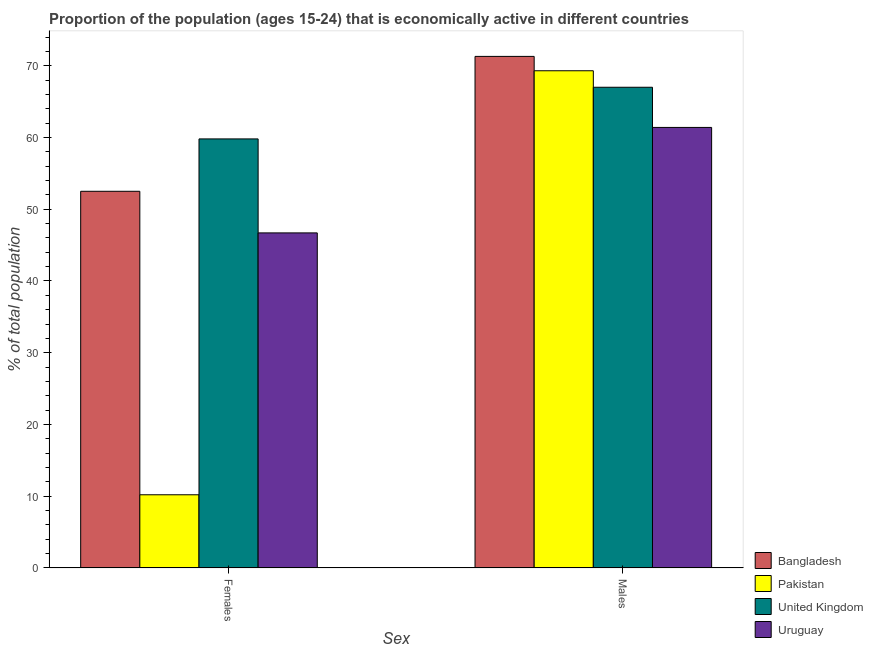How many different coloured bars are there?
Offer a terse response. 4. How many groups of bars are there?
Provide a succinct answer. 2. How many bars are there on the 1st tick from the left?
Ensure brevity in your answer.  4. How many bars are there on the 1st tick from the right?
Provide a succinct answer. 4. What is the label of the 2nd group of bars from the left?
Your answer should be compact. Males. What is the percentage of economically active female population in Pakistan?
Your answer should be very brief. 10.2. Across all countries, what is the maximum percentage of economically active male population?
Give a very brief answer. 71.3. Across all countries, what is the minimum percentage of economically active female population?
Your answer should be very brief. 10.2. In which country was the percentage of economically active female population maximum?
Make the answer very short. United Kingdom. In which country was the percentage of economically active male population minimum?
Keep it short and to the point. Uruguay. What is the total percentage of economically active female population in the graph?
Keep it short and to the point. 169.2. What is the difference between the percentage of economically active male population in Bangladesh and that in Pakistan?
Provide a short and direct response. 2. What is the difference between the percentage of economically active male population in Bangladesh and the percentage of economically active female population in United Kingdom?
Provide a short and direct response. 11.5. What is the average percentage of economically active female population per country?
Offer a terse response. 42.3. What is the difference between the percentage of economically active female population and percentage of economically active male population in United Kingdom?
Offer a terse response. -7.2. What is the ratio of the percentage of economically active male population in Bangladesh to that in Pakistan?
Offer a very short reply. 1.03. Is the percentage of economically active female population in United Kingdom less than that in Pakistan?
Your response must be concise. No. What does the 3rd bar from the left in Males represents?
Your response must be concise. United Kingdom. What does the 1st bar from the right in Males represents?
Provide a succinct answer. Uruguay. Are all the bars in the graph horizontal?
Give a very brief answer. No. How many countries are there in the graph?
Make the answer very short. 4. What is the difference between two consecutive major ticks on the Y-axis?
Make the answer very short. 10. Does the graph contain grids?
Your answer should be compact. No. Where does the legend appear in the graph?
Give a very brief answer. Bottom right. How many legend labels are there?
Provide a short and direct response. 4. What is the title of the graph?
Give a very brief answer. Proportion of the population (ages 15-24) that is economically active in different countries. Does "Italy" appear as one of the legend labels in the graph?
Offer a very short reply. No. What is the label or title of the X-axis?
Offer a terse response. Sex. What is the label or title of the Y-axis?
Your response must be concise. % of total population. What is the % of total population in Bangladesh in Females?
Make the answer very short. 52.5. What is the % of total population of Pakistan in Females?
Your answer should be very brief. 10.2. What is the % of total population in United Kingdom in Females?
Your response must be concise. 59.8. What is the % of total population in Uruguay in Females?
Offer a terse response. 46.7. What is the % of total population in Bangladesh in Males?
Offer a terse response. 71.3. What is the % of total population of Pakistan in Males?
Offer a very short reply. 69.3. What is the % of total population in Uruguay in Males?
Provide a succinct answer. 61.4. Across all Sex, what is the maximum % of total population in Bangladesh?
Provide a short and direct response. 71.3. Across all Sex, what is the maximum % of total population of Pakistan?
Your answer should be compact. 69.3. Across all Sex, what is the maximum % of total population of United Kingdom?
Make the answer very short. 67. Across all Sex, what is the maximum % of total population of Uruguay?
Your response must be concise. 61.4. Across all Sex, what is the minimum % of total population in Bangladesh?
Offer a terse response. 52.5. Across all Sex, what is the minimum % of total population of Pakistan?
Provide a succinct answer. 10.2. Across all Sex, what is the minimum % of total population of United Kingdom?
Make the answer very short. 59.8. Across all Sex, what is the minimum % of total population in Uruguay?
Your answer should be compact. 46.7. What is the total % of total population of Bangladesh in the graph?
Make the answer very short. 123.8. What is the total % of total population of Pakistan in the graph?
Your answer should be compact. 79.5. What is the total % of total population in United Kingdom in the graph?
Give a very brief answer. 126.8. What is the total % of total population of Uruguay in the graph?
Give a very brief answer. 108.1. What is the difference between the % of total population in Bangladesh in Females and that in Males?
Keep it short and to the point. -18.8. What is the difference between the % of total population of Pakistan in Females and that in Males?
Make the answer very short. -59.1. What is the difference between the % of total population of Uruguay in Females and that in Males?
Keep it short and to the point. -14.7. What is the difference between the % of total population in Bangladesh in Females and the % of total population in Pakistan in Males?
Make the answer very short. -16.8. What is the difference between the % of total population of Bangladesh in Females and the % of total population of Uruguay in Males?
Your answer should be compact. -8.9. What is the difference between the % of total population of Pakistan in Females and the % of total population of United Kingdom in Males?
Your answer should be very brief. -56.8. What is the difference between the % of total population of Pakistan in Females and the % of total population of Uruguay in Males?
Offer a terse response. -51.2. What is the difference between the % of total population of United Kingdom in Females and the % of total population of Uruguay in Males?
Ensure brevity in your answer.  -1.6. What is the average % of total population of Bangladesh per Sex?
Your answer should be compact. 61.9. What is the average % of total population in Pakistan per Sex?
Give a very brief answer. 39.75. What is the average % of total population in United Kingdom per Sex?
Provide a short and direct response. 63.4. What is the average % of total population in Uruguay per Sex?
Provide a succinct answer. 54.05. What is the difference between the % of total population of Bangladesh and % of total population of Pakistan in Females?
Provide a succinct answer. 42.3. What is the difference between the % of total population in Bangladesh and % of total population in United Kingdom in Females?
Keep it short and to the point. -7.3. What is the difference between the % of total population in Bangladesh and % of total population in Uruguay in Females?
Provide a short and direct response. 5.8. What is the difference between the % of total population in Pakistan and % of total population in United Kingdom in Females?
Make the answer very short. -49.6. What is the difference between the % of total population of Pakistan and % of total population of Uruguay in Females?
Your answer should be very brief. -36.5. What is the difference between the % of total population in United Kingdom and % of total population in Uruguay in Females?
Your response must be concise. 13.1. What is the difference between the % of total population of Bangladesh and % of total population of Pakistan in Males?
Your response must be concise. 2. What is the ratio of the % of total population of Bangladesh in Females to that in Males?
Ensure brevity in your answer.  0.74. What is the ratio of the % of total population of Pakistan in Females to that in Males?
Offer a terse response. 0.15. What is the ratio of the % of total population in United Kingdom in Females to that in Males?
Provide a succinct answer. 0.89. What is the ratio of the % of total population of Uruguay in Females to that in Males?
Keep it short and to the point. 0.76. What is the difference between the highest and the second highest % of total population in Bangladesh?
Offer a very short reply. 18.8. What is the difference between the highest and the second highest % of total population of Pakistan?
Provide a short and direct response. 59.1. What is the difference between the highest and the lowest % of total population in Bangladesh?
Keep it short and to the point. 18.8. What is the difference between the highest and the lowest % of total population in Pakistan?
Provide a succinct answer. 59.1. 